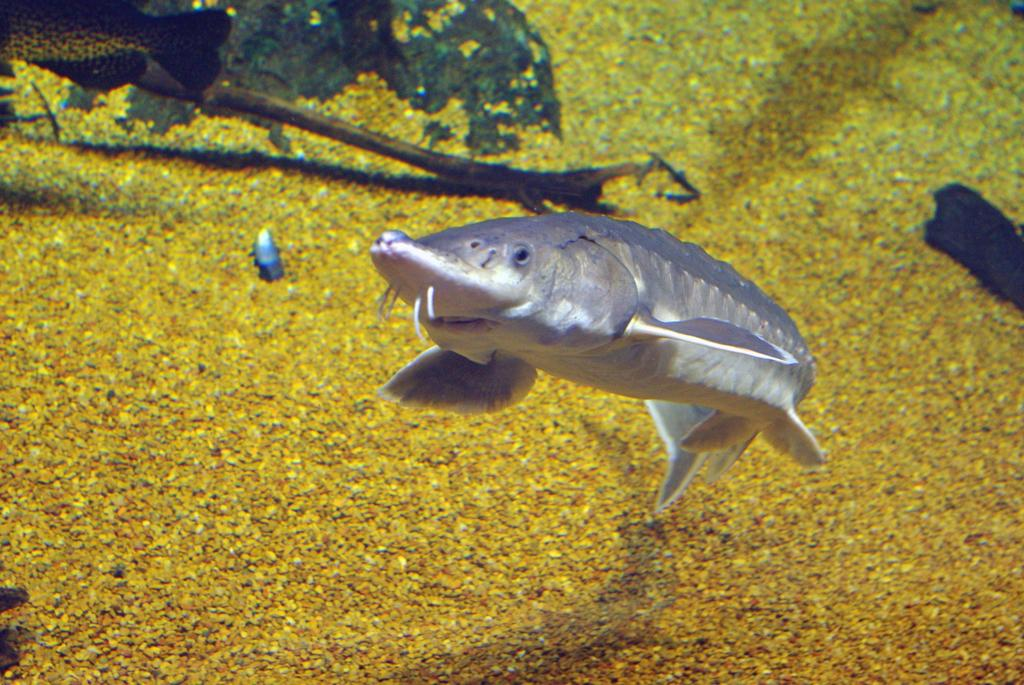What type of animal is present in the image? There is a fish in the image. Can you describe the part of the fish that is visible in the top left corner of the image? There is a partial part of a fish visible in the top left corner of the image. What type of shelf can be seen holding the fish in the image? There is no shelf present in the image; it features a fish. 